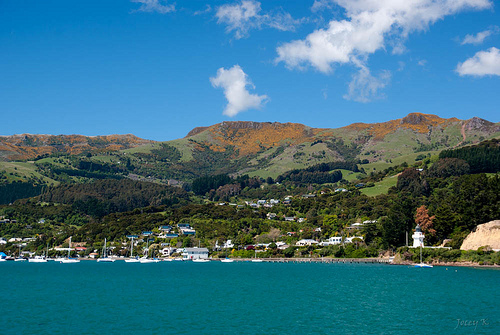<image>
Is there a mountain behind the water? Yes. From this viewpoint, the mountain is positioned behind the water, with the water partially or fully occluding the mountain. 